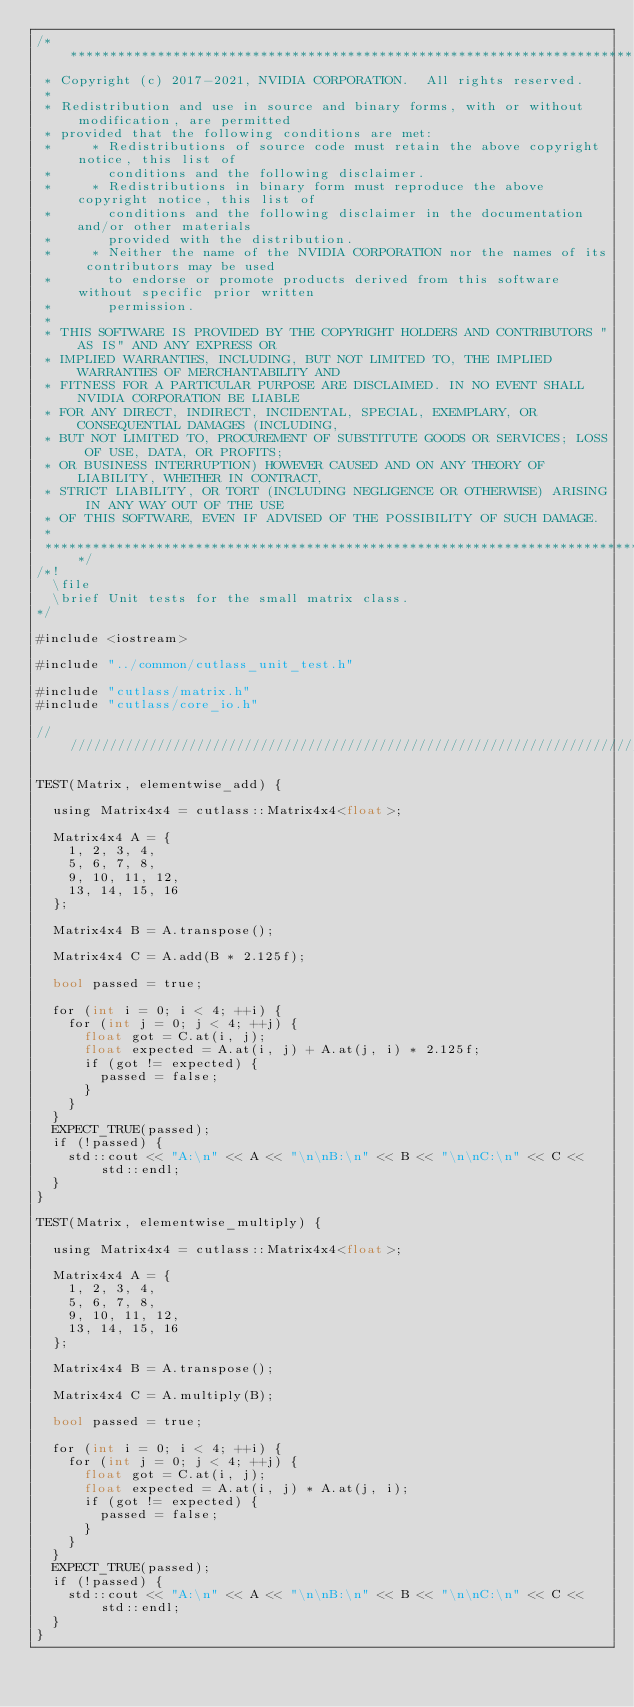<code> <loc_0><loc_0><loc_500><loc_500><_Cuda_>/***************************************************************************************************
 * Copyright (c) 2017-2021, NVIDIA CORPORATION.  All rights reserved.
 *
 * Redistribution and use in source and binary forms, with or without modification, are permitted
 * provided that the following conditions are met:
 *     * Redistributions of source code must retain the above copyright notice, this list of
 *       conditions and the following disclaimer.
 *     * Redistributions in binary form must reproduce the above copyright notice, this list of
 *       conditions and the following disclaimer in the documentation and/or other materials
 *       provided with the distribution.
 *     * Neither the name of the NVIDIA CORPORATION nor the names of its contributors may be used
 *       to endorse or promote products derived from this software without specific prior written
 *       permission.
 *
 * THIS SOFTWARE IS PROVIDED BY THE COPYRIGHT HOLDERS AND CONTRIBUTORS "AS IS" AND ANY EXPRESS OR
 * IMPLIED WARRANTIES, INCLUDING, BUT NOT LIMITED TO, THE IMPLIED WARRANTIES OF MERCHANTABILITY AND
 * FITNESS FOR A PARTICULAR PURPOSE ARE DISCLAIMED. IN NO EVENT SHALL NVIDIA CORPORATION BE LIABLE
 * FOR ANY DIRECT, INDIRECT, INCIDENTAL, SPECIAL, EXEMPLARY, OR CONSEQUENTIAL DAMAGES (INCLUDING,
 * BUT NOT LIMITED TO, PROCUREMENT OF SUBSTITUTE GOODS OR SERVICES; LOSS OF USE, DATA, OR PROFITS;
 * OR BUSINESS INTERRUPTION) HOWEVER CAUSED AND ON ANY THEORY OF LIABILITY, WHETHER IN CONTRACT,
 * STRICT LIABILITY, OR TORT (INCLUDING NEGLIGENCE OR OTHERWISE) ARISING IN ANY WAY OUT OF THE USE
 * OF THIS SOFTWARE, EVEN IF ADVISED OF THE POSSIBILITY OF SUCH DAMAGE.
 *
 **************************************************************************************************/
/*! 
  \file
  \brief Unit tests for the small matrix class.
*/

#include <iostream>

#include "../common/cutlass_unit_test.h"

#include "cutlass/matrix.h"
#include "cutlass/core_io.h"

/////////////////////////////////////////////////////////////////////////////////////////////////

TEST(Matrix, elementwise_add) {

  using Matrix4x4 = cutlass::Matrix4x4<float>;

  Matrix4x4 A = {
    1, 2, 3, 4,
    5, 6, 7, 8,
    9, 10, 11, 12,
    13, 14, 15, 16
  };

  Matrix4x4 B = A.transpose();

  Matrix4x4 C = A.add(B * 2.125f);

  bool passed = true;

  for (int i = 0; i < 4; ++i) {
    for (int j = 0; j < 4; ++j) {
      float got = C.at(i, j);
      float expected = A.at(i, j) + A.at(j, i) * 2.125f;
      if (got != expected) {
        passed = false;
      }
    }
  }
  EXPECT_TRUE(passed);
  if (!passed) {
    std::cout << "A:\n" << A << "\n\nB:\n" << B << "\n\nC:\n" << C << std::endl;
  }
}

TEST(Matrix, elementwise_multiply) {

  using Matrix4x4 = cutlass::Matrix4x4<float>;

  Matrix4x4 A = {
    1, 2, 3, 4,
    5, 6, 7, 8,
    9, 10, 11, 12,
    13, 14, 15, 16
  };

  Matrix4x4 B = A.transpose();

  Matrix4x4 C = A.multiply(B);

  bool passed = true;

  for (int i = 0; i < 4; ++i) {
    for (int j = 0; j < 4; ++j) {
      float got = C.at(i, j);
      float expected = A.at(i, j) * A.at(j, i);
      if (got != expected) {
        passed = false;
      }
    }
  }
  EXPECT_TRUE(passed);
  if (!passed) {
    std::cout << "A:\n" << A << "\n\nB:\n" << B << "\n\nC:\n" << C << std::endl;
  }
}
</code> 